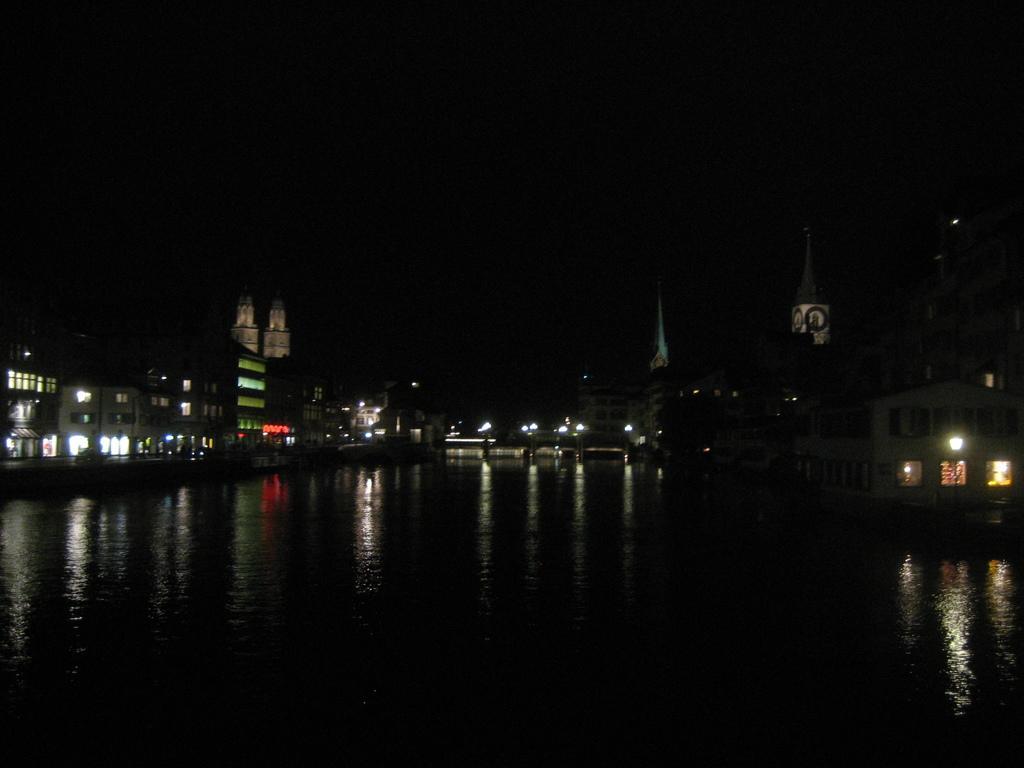Please provide a concise description of this image. It is the image of a city, it is captured in the night time. There is a river and beside the river there are a lot of buildings and towers. The view is very beautiful as the buildings are lightened up with the lights. 